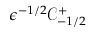Convert formula to latex. <formula><loc_0><loc_0><loc_500><loc_500>\epsilon ^ { - 1 / 2 } \mathcal { C } _ { - 1 / 2 } ^ { + }</formula> 